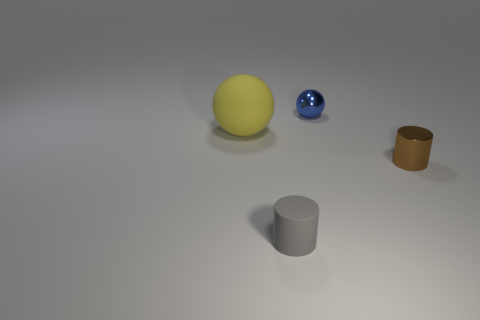The metal thing that is the same size as the brown shiny cylinder is what color?
Keep it short and to the point. Blue. How many metallic objects are tiny brown things or purple balls?
Offer a terse response. 1. There is a cylinder that is made of the same material as the blue thing; what color is it?
Your response must be concise. Brown. What is the material of the thing that is left of the matte object that is right of the large yellow matte ball?
Offer a very short reply. Rubber. How many things are tiny objects on the left side of the tiny blue shiny sphere or cylinders on the left side of the tiny blue shiny object?
Give a very brief answer. 1. There is a cylinder to the right of the cylinder that is to the left of the tiny object behind the large sphere; how big is it?
Provide a succinct answer. Small. Are there the same number of big yellow things that are to the right of the small metallic ball and tiny purple matte blocks?
Give a very brief answer. Yes. There is a tiny blue object; does it have the same shape as the matte thing to the left of the gray cylinder?
Ensure brevity in your answer.  Yes. There is another object that is the same shape as the yellow object; what is its size?
Offer a terse response. Small. How many other things are there of the same material as the small gray cylinder?
Your answer should be very brief. 1. 